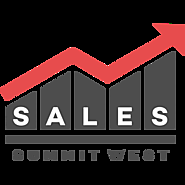What event could this logo be representing, and why is the directional designation 'WEST' significant? The logo most likely represents a business event known as the 'Sales Summit West,' concentrating on the western geographic areas or markets. The inclusion of 'WEST' suggests a regional focus, possibly targeting professionals and businesses based in western states or regions interested in enhancing their sales strategies and network. 